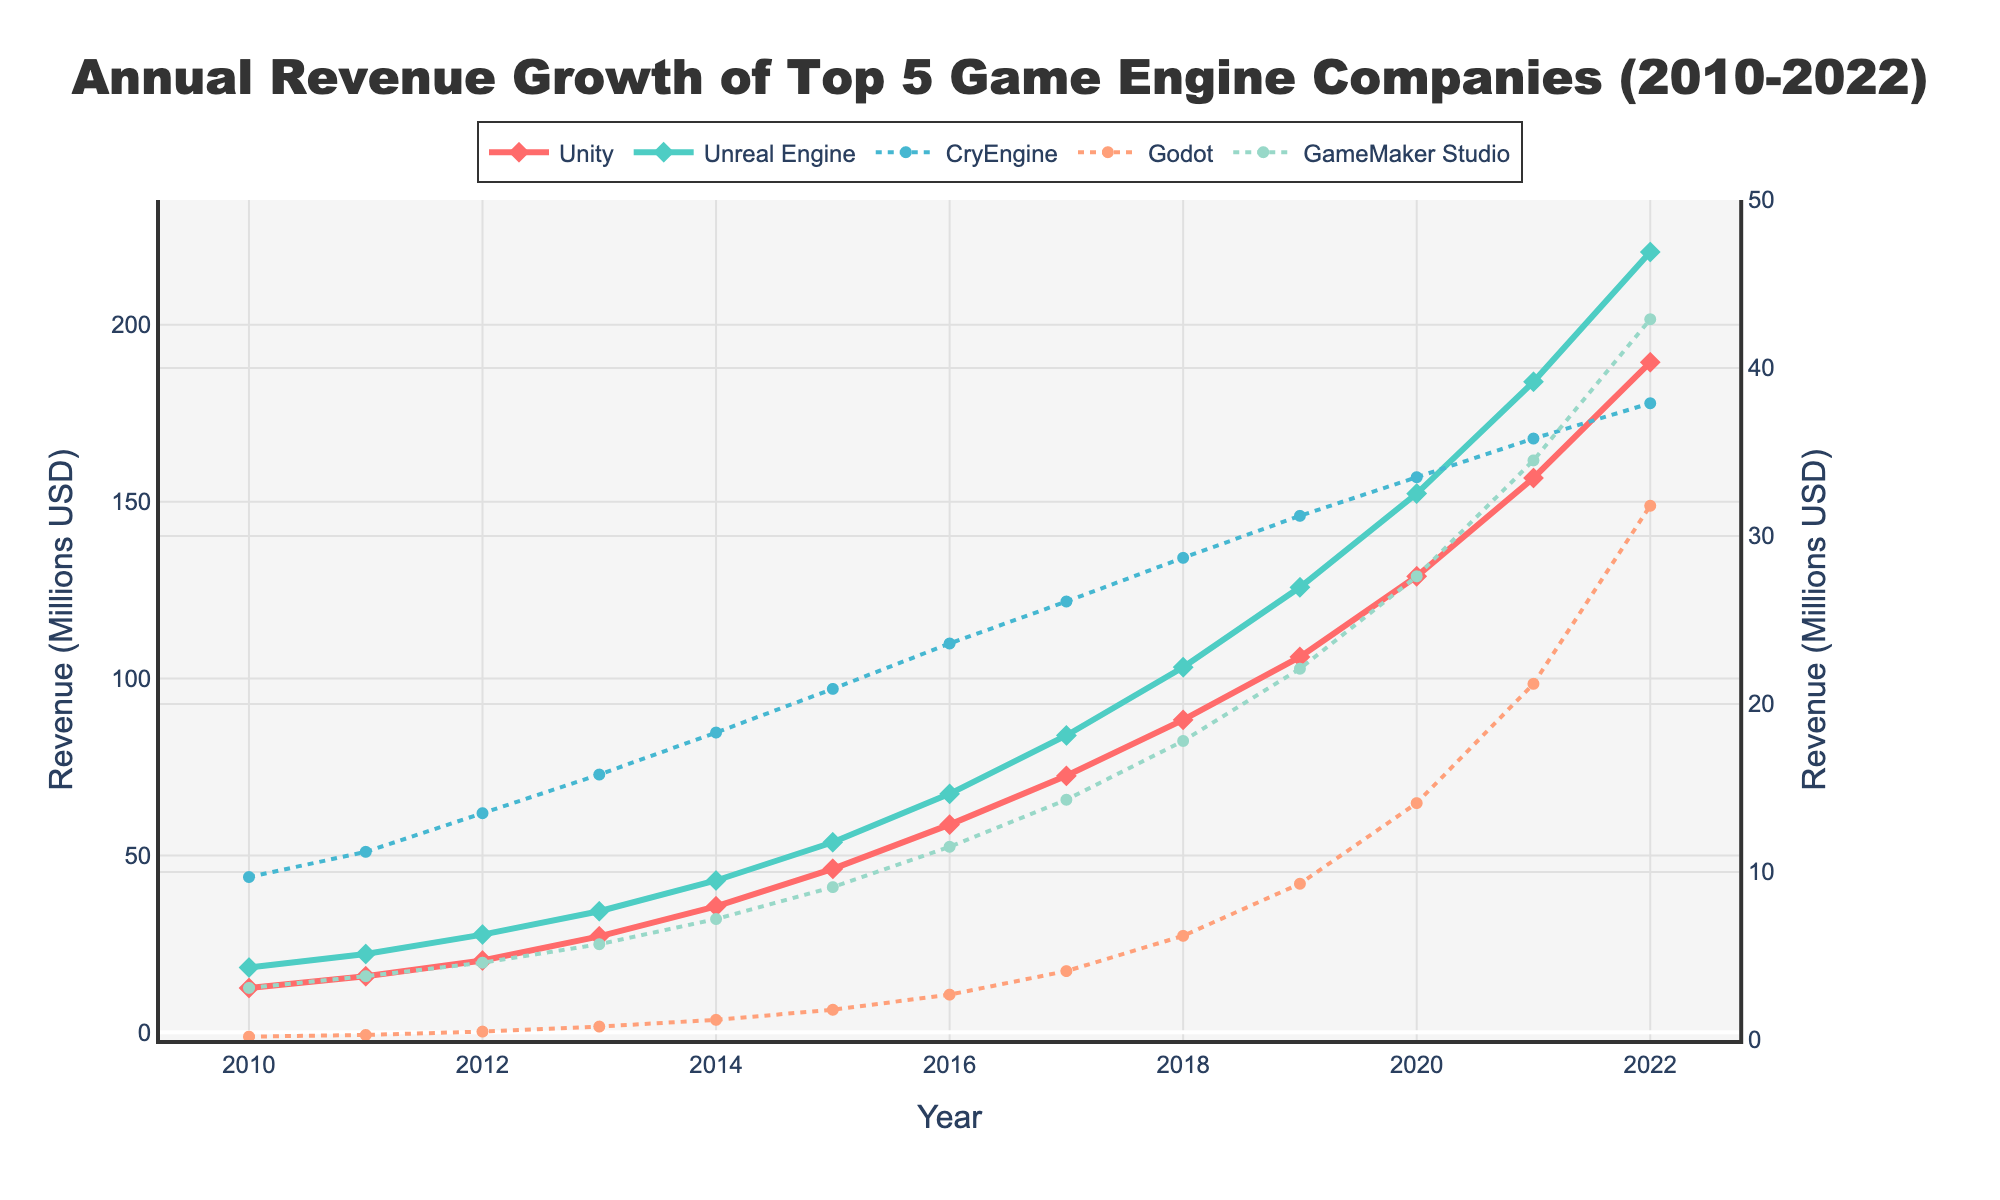What is the revenue difference between Unity and Unreal Engine in 2022? To find the revenue difference between Unity and Unreal Engine in 2022, subtract the revenue of Unreal Engine from the revenue of Unity: 220.6 (Unreal Engine) - 189.4 (Unity) = 31.2 million USD
Answer: 31.2 million USD Which game engine had the highest revenue growth from 2010 to 2022? Compare the revenue growth trajectories by examining the end values (2022) and the start values (2010). Unity had the highest growth, starting from 12.5 million USD in 2010 to 189.4 million USD in 2022
Answer: Unity How does the revenue of Godot in 2020 compare to that of GameMaker Studio in the same year? Check the values for Godot and GameMaker Studio in 2020. Godot's revenue is 14.1 million USD while GameMaker Studio's is 27.6 million USD. GameMaker Studio's revenue is higher by 27.6 - 14.1 = 13.5 million USD
Answer: GameMaker Studio is higher by 13.5 million USD What is the average annual revenue of CryEngine from 2010 to 2022? Sum all annual revenues for CryEngine from 2010 to 2022 and then divide by the number of years (13). (9.7 + 11.2 + 13.5 + 15.8 + 18.3 + 20.9 + 23.6 + 26.1 + 28.7 + 31.2 + 33.5 + 35.8 + 37.9) / 13 = 22.8 million USD
Answer: 22.8 million USD In what year did Unity overtake Unreal Engine in annual revenue? Check the data for the first year where Unity's revenue exceeds Unreal Engine's. This occurs in 2022 when Unity reaches 189.4 million USD and Unreal Engine reaches 220.6 million USD. So, the overtaking happens after the last data point
Answer: Not applicable by 2022 Which company had the lowest revenue in 2019, and what was the value? Look at the revenue values for each company in 2019. Godot had the lowest revenue at 9.3 million USD
Answer: Godot, 9.3 million USD What is the total revenue for GameMaker Studio from 2010 to 2022? Sum all annual revenues for GameMaker Studio from 2010 to 2022. 3.1 + 3.8 + 4.6 + 5.7 + 7.2 + 9.1 + 11.5 + 14.3 + 17.8 + 22.1 + 27.6 + 34.5 + 42.9 = 204.2 million USD
Answer: 204.2 million USD By how much did the revenue of Unreal Engine increase between 2017 and 2022? Subtract the revenue in 2017 from the revenue in 2022 for Unreal Engine. 220.6 - 83.9 = 136.7 million USD
Answer: 136.7 million USD Which game engine had consistent revenue growth every year? Check the yearly revenue data for consistency. All game engines listed had consistent growth every year
Answer: All What is the median revenue for Unity from 2010 to 2022? Arrange Unity’s revenues in ascending order: [12.5, 15.8, 20.3, 27.1, 35.6, 46.2, 58.7, 72.5, 88.3, 106.1, 128.9, 156.7, 189.4]. The median is the middle value: 58.7 million USD
Answer: 58.7 million USD 